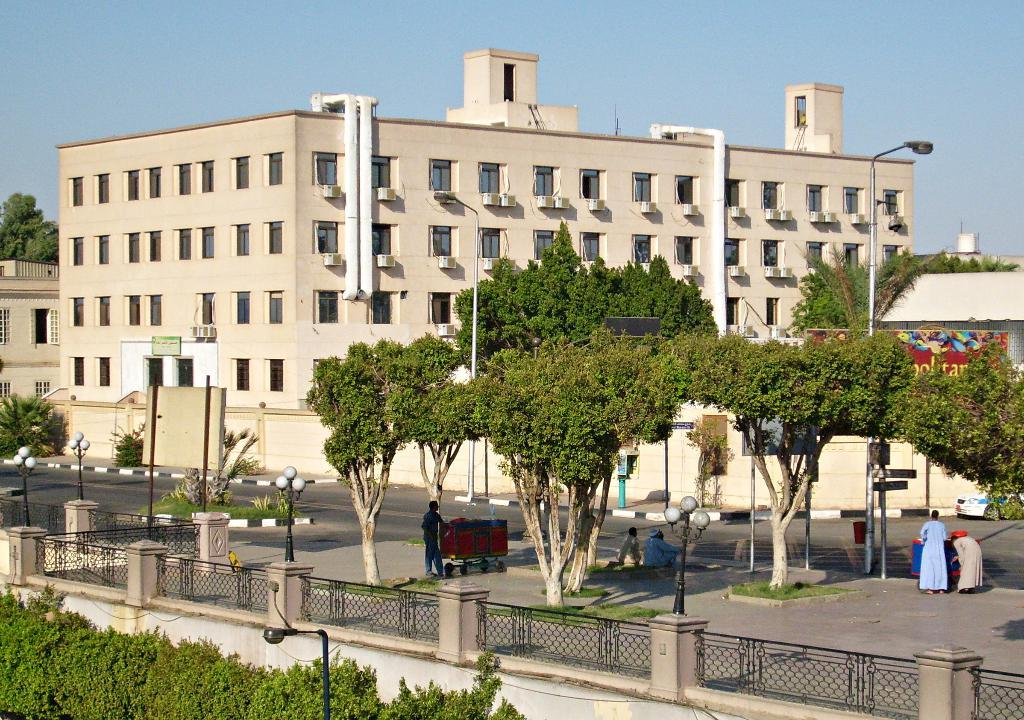What type of living organisms can be seen in the image? Plants, trees, and grass are visible in the image. What structures can be seen in the image? There is a wall, fences, boards on poles, and buildings visible in the image. What objects can be seen in the image? There are lights, carts, and a road visible in the image. What is present in the background of the image? In the background, there are walls, plants, buildings, a vehicle, trees, and sky visible. Are there any people in the image? Yes, there are people in the image. What type of wound can be seen on the team's star player in the image? There is no wound or team present in the image. What type of stove is being used by the people in the image? There is no stove present in the image. 